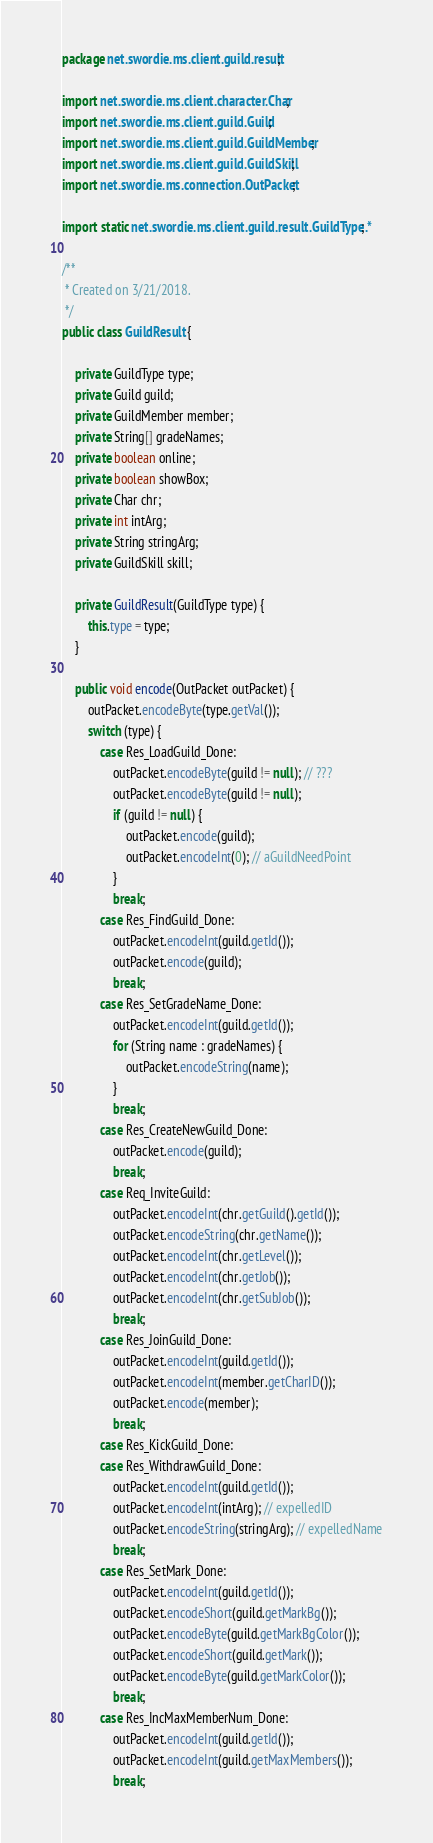<code> <loc_0><loc_0><loc_500><loc_500><_Java_>package net.swordie.ms.client.guild.result;

import net.swordie.ms.client.character.Char;
import net.swordie.ms.client.guild.Guild;
import net.swordie.ms.client.guild.GuildMember;
import net.swordie.ms.client.guild.GuildSkill;
import net.swordie.ms.connection.OutPacket;

import static net.swordie.ms.client.guild.result.GuildType.*;

/**
 * Created on 3/21/2018.
 */
public class GuildResult {

    private GuildType type;
    private Guild guild;
    private GuildMember member;
    private String[] gradeNames;
    private boolean online;
    private boolean showBox;
    private Char chr;
    private int intArg;
    private String stringArg;
    private GuildSkill skill;

    private GuildResult(GuildType type) {
        this.type = type;
    }

    public void encode(OutPacket outPacket) {
        outPacket.encodeByte(type.getVal());
        switch (type) {
            case Res_LoadGuild_Done:
                outPacket.encodeByte(guild != null); // ???
                outPacket.encodeByte(guild != null);
                if (guild != null) {
                    outPacket.encode(guild);
                    outPacket.encodeInt(0); // aGuildNeedPoint
                }
                break;
            case Res_FindGuild_Done:
                outPacket.encodeInt(guild.getId());
                outPacket.encode(guild);
                break;
            case Res_SetGradeName_Done:
                outPacket.encodeInt(guild.getId());
                for (String name : gradeNames) {
                    outPacket.encodeString(name);
                }
                break;
            case Res_CreateNewGuild_Done:
                outPacket.encode(guild);
                break;
            case Req_InviteGuild:
                outPacket.encodeInt(chr.getGuild().getId());
                outPacket.encodeString(chr.getName());
                outPacket.encodeInt(chr.getLevel());
                outPacket.encodeInt(chr.getJob());
                outPacket.encodeInt(chr.getSubJob());
                break;
            case Res_JoinGuild_Done:
                outPacket.encodeInt(guild.getId());
                outPacket.encodeInt(member.getCharID());
                outPacket.encode(member);
                break;
            case Res_KickGuild_Done:
            case Res_WithdrawGuild_Done:
                outPacket.encodeInt(guild.getId());
                outPacket.encodeInt(intArg); // expelledID
                outPacket.encodeString(stringArg); // expelledName
                break;
            case Res_SetMark_Done:
                outPacket.encodeInt(guild.getId());
                outPacket.encodeShort(guild.getMarkBg());
                outPacket.encodeByte(guild.getMarkBgColor());
                outPacket.encodeShort(guild.getMark());
                outPacket.encodeByte(guild.getMarkColor());
                break;
            case Res_IncMaxMemberNum_Done:
                outPacket.encodeInt(guild.getId());
                outPacket.encodeInt(guild.getMaxMembers());
                break;</code> 